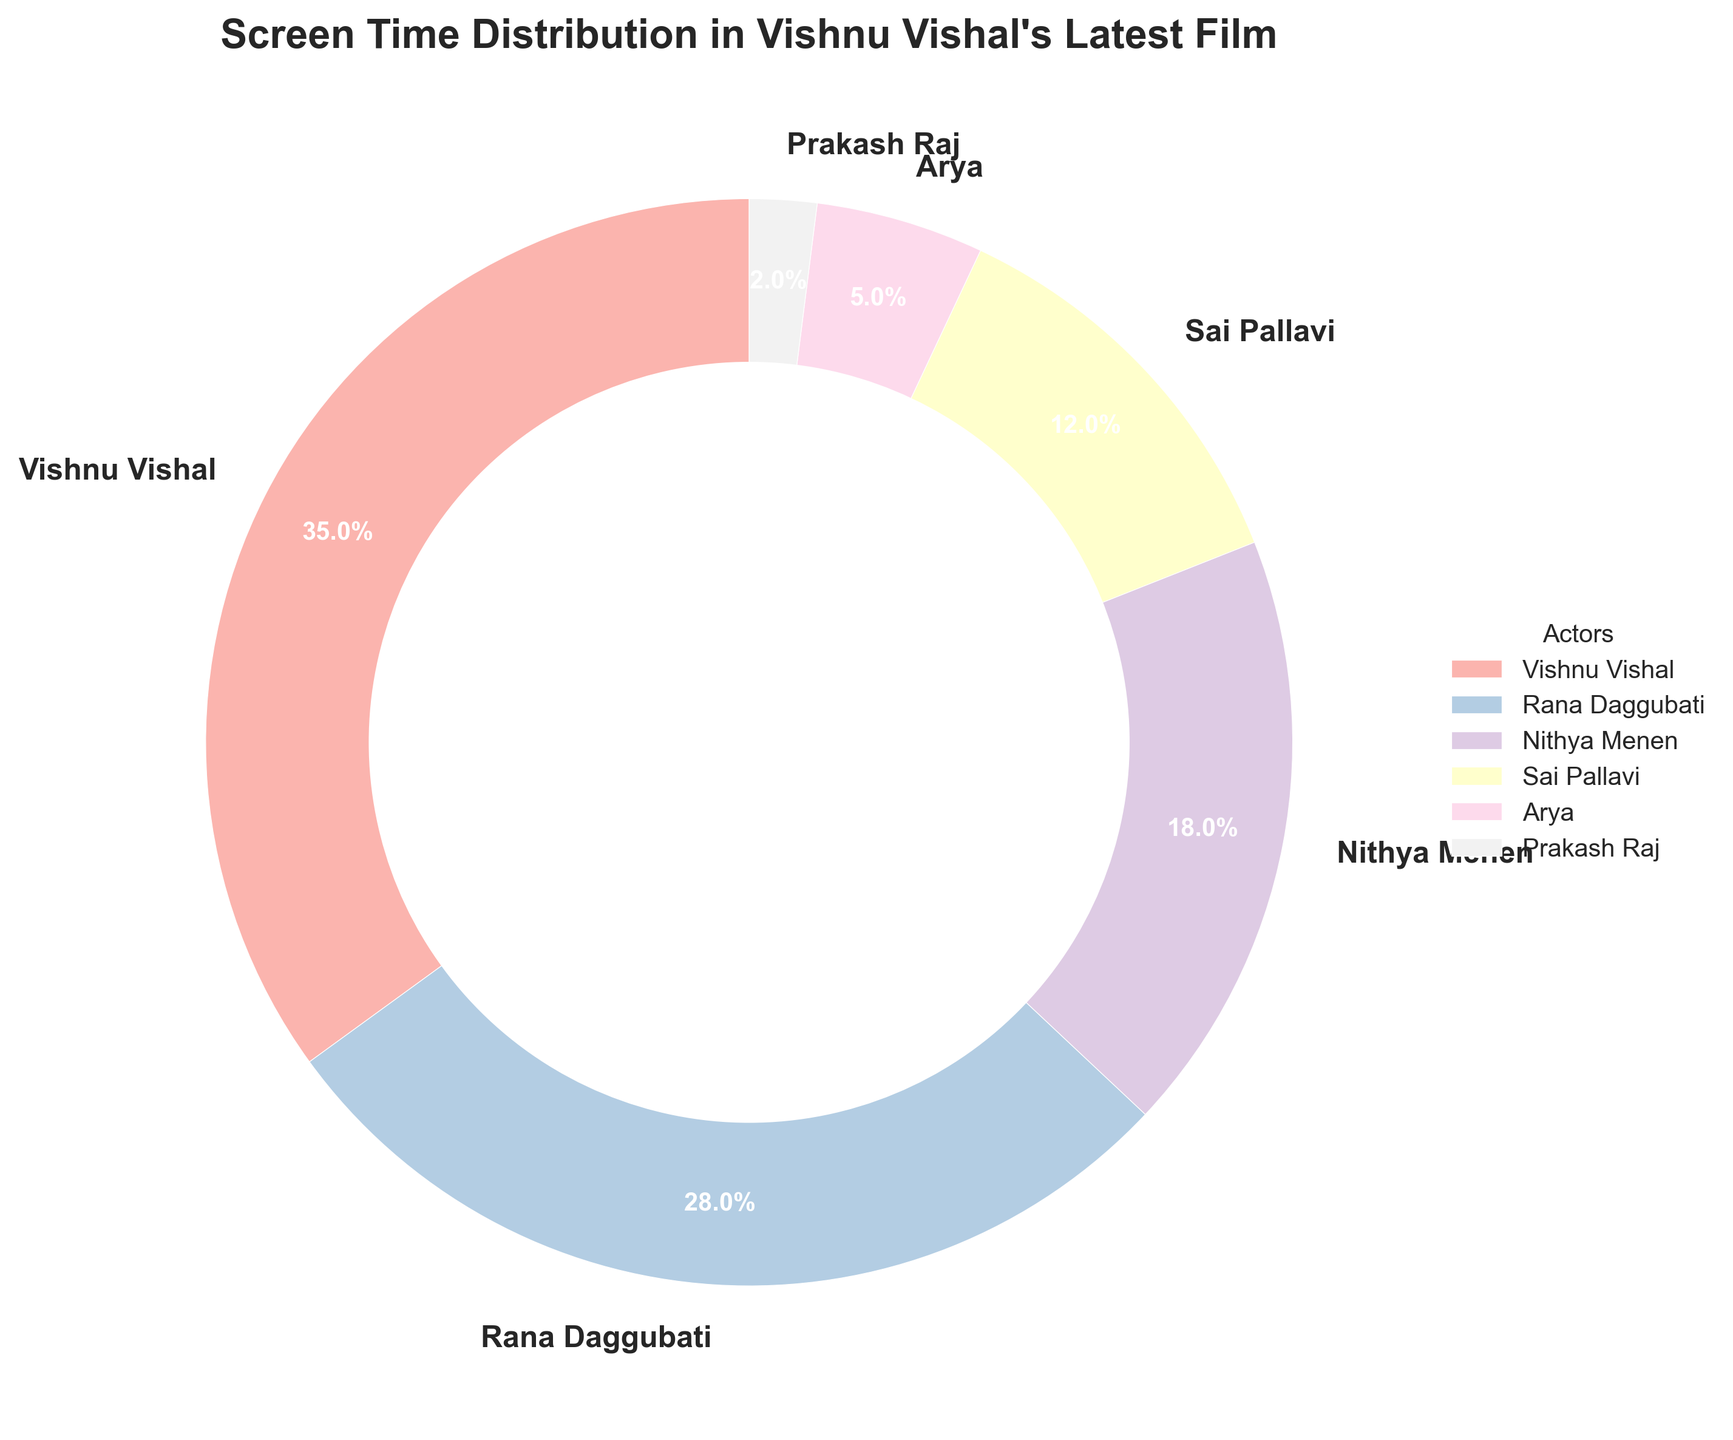What's the percentage of screen time allocated to Vishnu Vishal and Rana Daggubati combined? To find the combined screen time, add the individual percentages allocated to Vishnu Vishal (35%) and Rana Daggubati (28%). Therefore, 35% + 28% = 63%.
Answer: 63% Who gets more screen time, Sai Pallavi or Nithya Menen, and by how much? Nithya Menen gets 18% of the screen time while Sai Pallavi gets 12%. The difference in their screen time is calculated as 18% - 12% = 6%.
Answer: Nithya Menen by 6% Which actor has the least screen time, and what percentage does it represent? According to the plot, Prakash Raj has the least screen time with 2%.
Answer: Prakash Raj, 2% How does the combined screen time of Arya and Prakash Raj compare to that of Sai Pallavi? Arya and Prakash Raj together have 5% + 2% = 7% screen time. Sai Pallavi has 12% screen time. Comparing these, Sai Pallavi has 12% - 7% = 5% more screen time than Arya and Prakash Raj combined.
Answer: Sai Pallavi has 5% more What's the ratio of screen time between Vishnu Vishal and Nithya Menen? Vishnu Vishal's screen time is 35%, and Nithya Menen's is 18%. The ratio of their screen times is 35:18. Simplifying the fraction, we get 35/18 = 1.944, approximately 1.94:1.
Answer: 1.94:1 What portion of the pie chart is taken up by the top three actors in terms of screen time? The top three actors are Vishnu Vishal (35%), Rana Daggubati (28%), and Nithya Menen (18%). Adding their screen times together gives us 35% + 28% + 18% = 81%.
Answer: 81% Which actor has the second highest screen time, and how much less is it compared to the highest screen time? Rana Daggubati has the second highest screen time at 28%. Vishnu Vishal has the highest screen time at 35%. The difference between them is 35% - 28% = 7%.
Answer: Rana Daggubati, 7% How many actors have more than 20% screen time? The actors who have more than 20% screen time are Vishnu Vishal (35%) and Rana Daggubati (28%). So, there are 2 actors with more than 20% screen time.
Answer: 2 If the screen time of Vishnu Vishal was reduced by 10%, how would it compare with Rana Daggubati's screen time then? If Vishnu Vishal’s screen time is reduced by 10%, his new screen time would be 35% - 10% = 25%. Comparing it with Rana Daggubati’s screen time of 28%, Rana Daggubati would have 28% - 25% = 3% more screen time.
Answer: Rana Daggubati has 3% more 